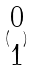Convert formula to latex. <formula><loc_0><loc_0><loc_500><loc_500>( \begin{matrix} 0 \\ 1 \end{matrix} )</formula> 